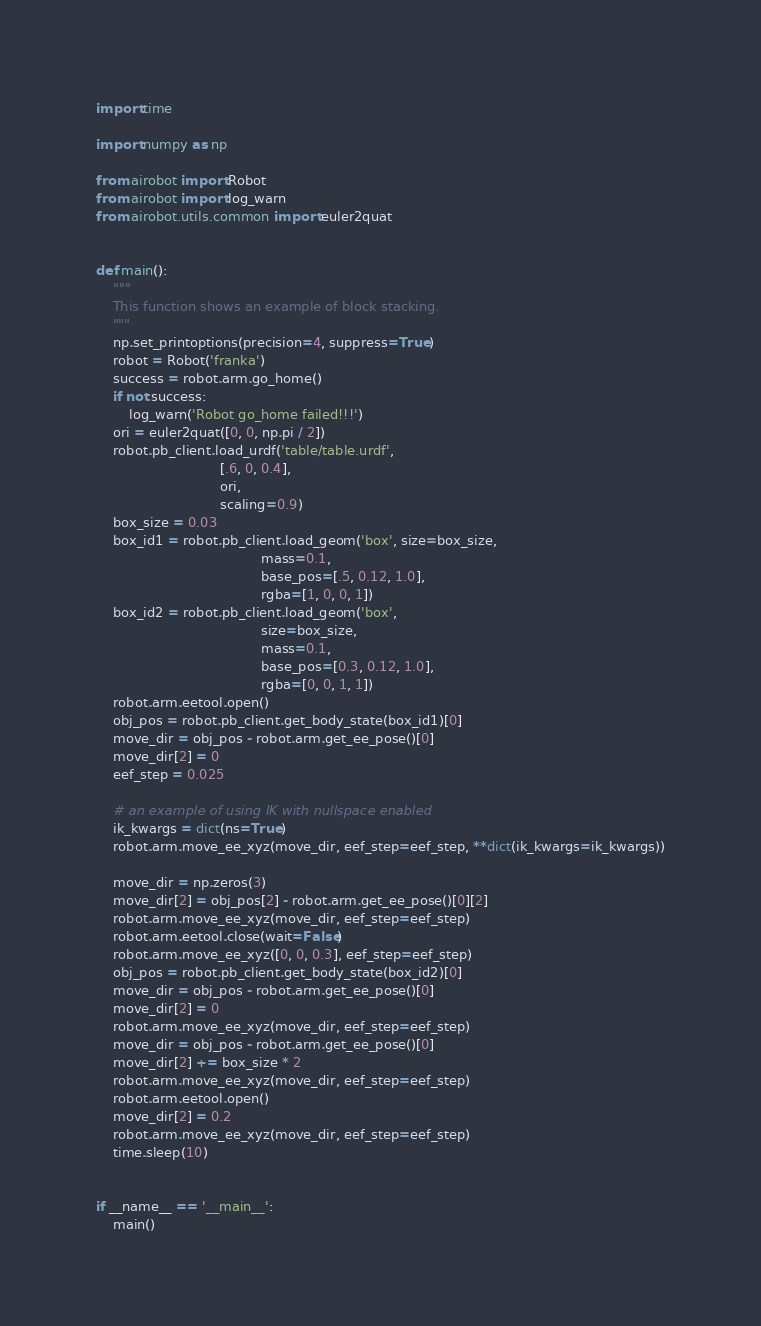Convert code to text. <code><loc_0><loc_0><loc_500><loc_500><_Python_>import time

import numpy as np

from airobot import Robot
from airobot import log_warn
from airobot.utils.common import euler2quat


def main():
    """
    This function shows an example of block stacking.
    """
    np.set_printoptions(precision=4, suppress=True)
    robot = Robot('franka')
    success = robot.arm.go_home()
    if not success:
        log_warn('Robot go_home failed!!!')
    ori = euler2quat([0, 0, np.pi / 2])
    robot.pb_client.load_urdf('table/table.urdf',
                              [.6, 0, 0.4],
                              ori,
                              scaling=0.9)
    box_size = 0.03
    box_id1 = robot.pb_client.load_geom('box', size=box_size,
                                        mass=0.1,
                                        base_pos=[.5, 0.12, 1.0],
                                        rgba=[1, 0, 0, 1])
    box_id2 = robot.pb_client.load_geom('box',
                                        size=box_size,
                                        mass=0.1,
                                        base_pos=[0.3, 0.12, 1.0],
                                        rgba=[0, 0, 1, 1])
    robot.arm.eetool.open()
    obj_pos = robot.pb_client.get_body_state(box_id1)[0]
    move_dir = obj_pos - robot.arm.get_ee_pose()[0]
    move_dir[2] = 0
    eef_step = 0.025

    # an example of using IK with nullspace enabled
    ik_kwargs = dict(ns=True)
    robot.arm.move_ee_xyz(move_dir, eef_step=eef_step, **dict(ik_kwargs=ik_kwargs))

    move_dir = np.zeros(3)
    move_dir[2] = obj_pos[2] - robot.arm.get_ee_pose()[0][2]
    robot.arm.move_ee_xyz(move_dir, eef_step=eef_step)
    robot.arm.eetool.close(wait=False)
    robot.arm.move_ee_xyz([0, 0, 0.3], eef_step=eef_step)
    obj_pos = robot.pb_client.get_body_state(box_id2)[0]
    move_dir = obj_pos - robot.arm.get_ee_pose()[0]
    move_dir[2] = 0
    robot.arm.move_ee_xyz(move_dir, eef_step=eef_step)
    move_dir = obj_pos - robot.arm.get_ee_pose()[0]
    move_dir[2] += box_size * 2
    robot.arm.move_ee_xyz(move_dir, eef_step=eef_step)
    robot.arm.eetool.open()
    move_dir[2] = 0.2
    robot.arm.move_ee_xyz(move_dir, eef_step=eef_step)
    time.sleep(10)


if __name__ == '__main__':
    main()
</code> 